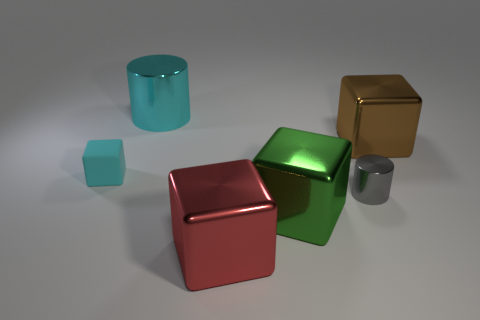What size is the object that is behind the object right of the metallic cylinder in front of the big cyan cylinder?
Offer a terse response. Large. The thing that is the same size as the cyan rubber cube is what shape?
Offer a terse response. Cylinder. Is there any other thing that has the same material as the big green cube?
Offer a terse response. Yes. What number of things are either shiny cylinders right of the cyan metallic cylinder or big metallic blocks?
Make the answer very short. 4. Are there any red objects that are on the right side of the metallic cylinder in front of the big block that is behind the large green metallic object?
Your answer should be compact. No. What number of large cyan rubber objects are there?
Make the answer very short. 0. What number of things are shiny things left of the big brown metal block or cyan things that are behind the brown cube?
Give a very brief answer. 4. Do the shiny block to the right of the gray cylinder and the tiny cylinder have the same size?
Provide a short and direct response. No. There is a cyan rubber object that is the same shape as the big brown shiny thing; what size is it?
Give a very brief answer. Small. What is the material of the gray cylinder that is the same size as the cyan cube?
Your response must be concise. Metal. 